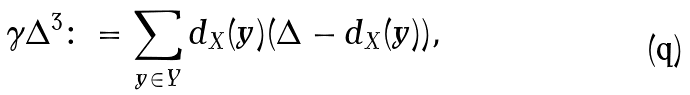Convert formula to latex. <formula><loc_0><loc_0><loc_500><loc_500>\gamma \Delta ^ { 3 } \colon = \sum _ { y \in Y } d _ { X } ( y ) ( \Delta - d _ { X } ( y ) ) ,</formula> 